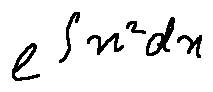Convert formula to latex. <formula><loc_0><loc_0><loc_500><loc_500>e ^ { \int x ^ { 2 } d x }</formula> 